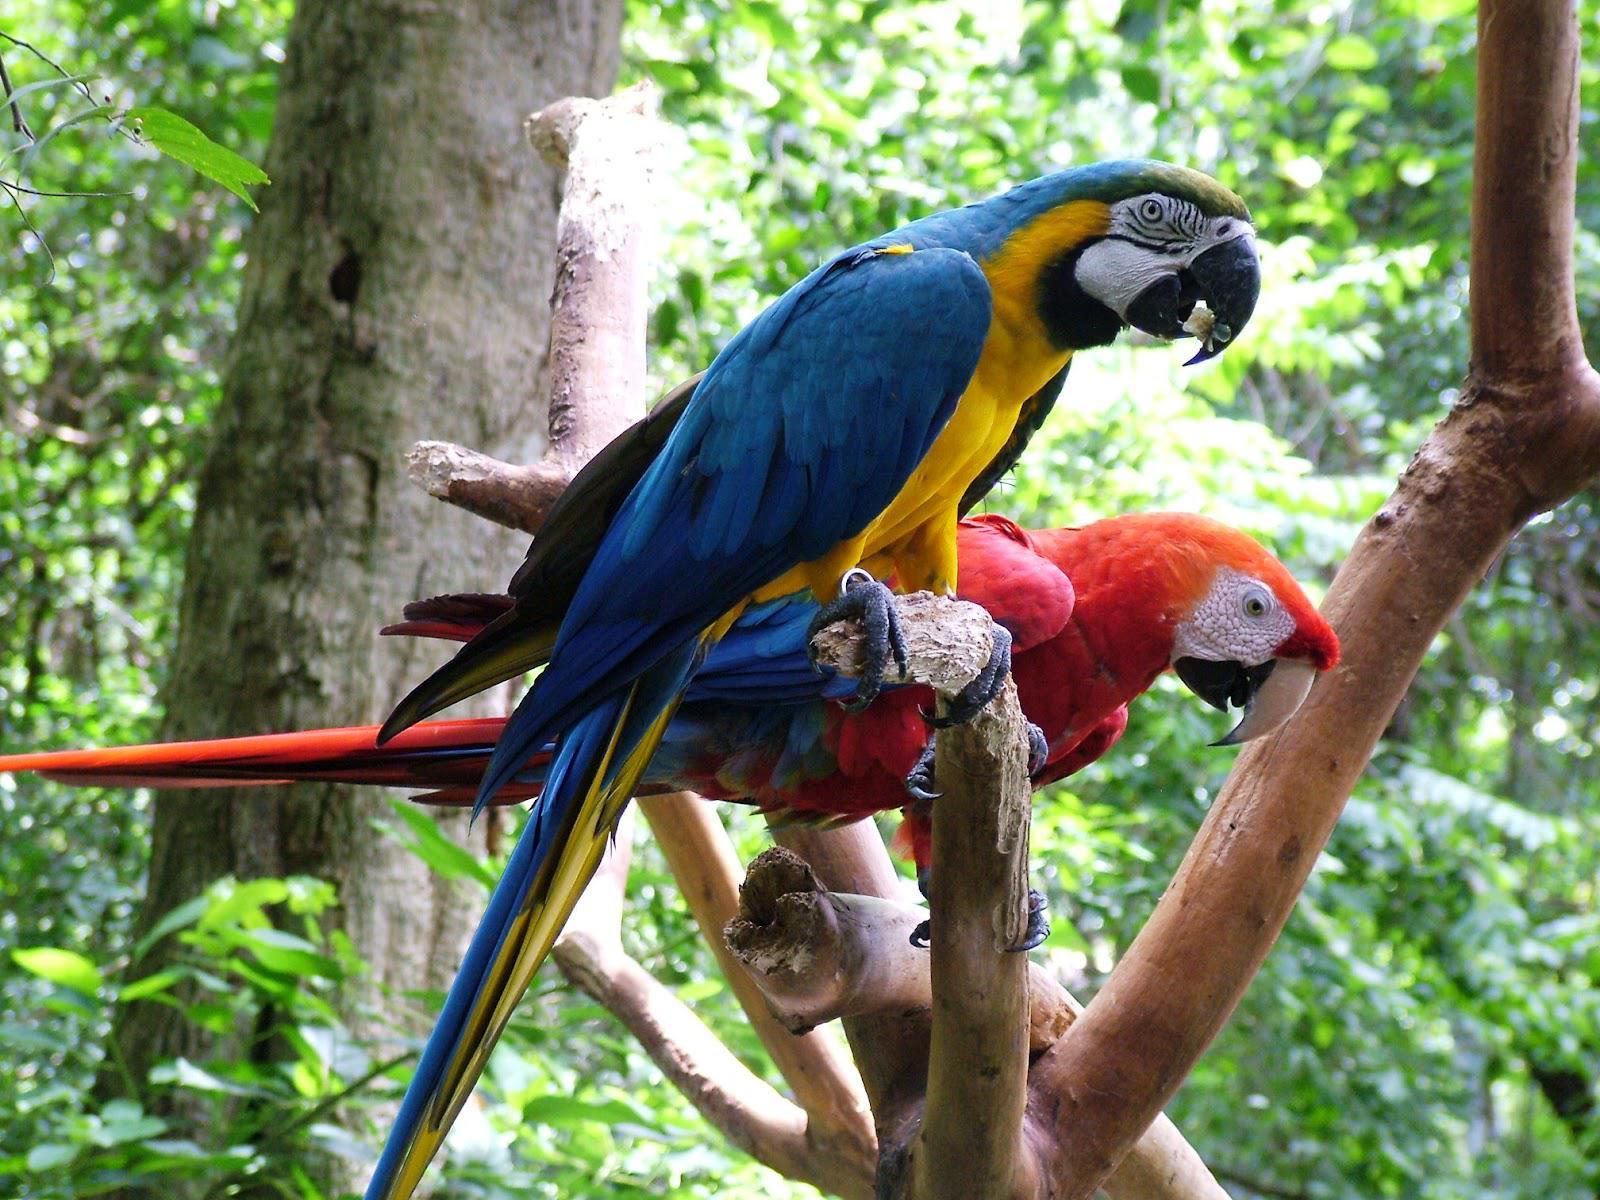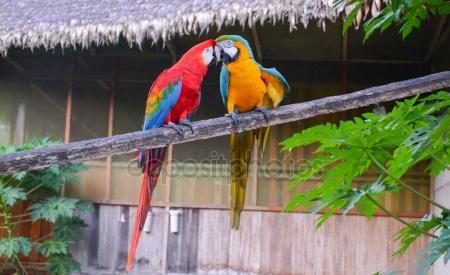The first image is the image on the left, the second image is the image on the right. Given the left and right images, does the statement "The right image features at least six blue parrots." hold true? Answer yes or no. No. 